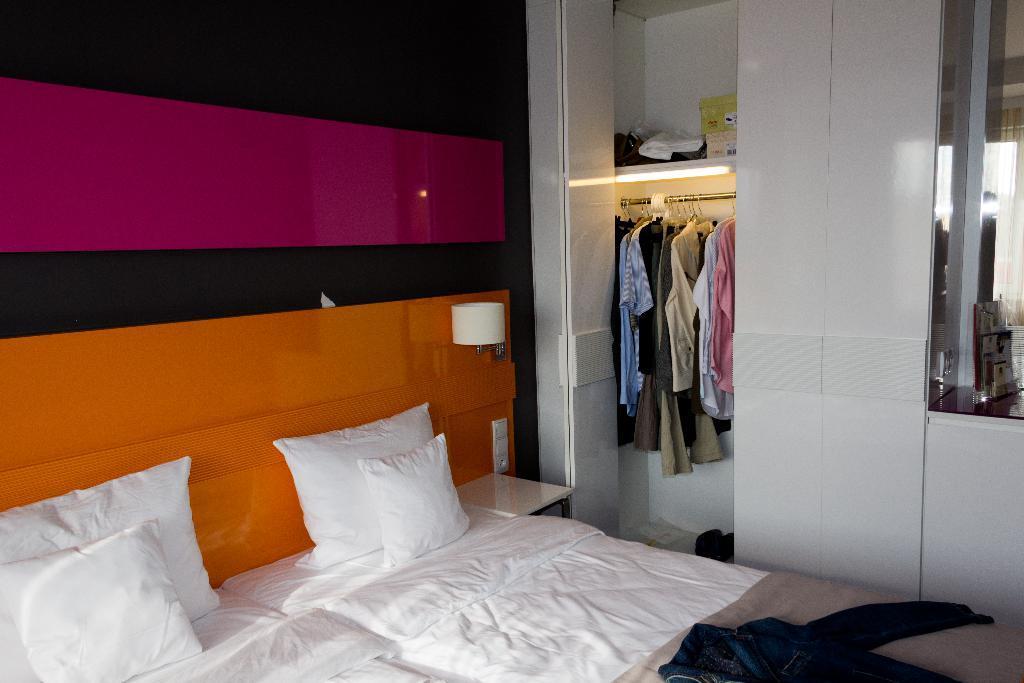Please provide a concise description of this image. This is the picture of a room. In this image there are pillows and there is a dress on the bed. At the back there are clothes inside the cupboard and there are boxes and there is a light inside the cupboard. On the right side of the image there is a mirror and there is a reflection of a table and curtain on the mirror. At the back there is a lamp and switch board on the wall. 